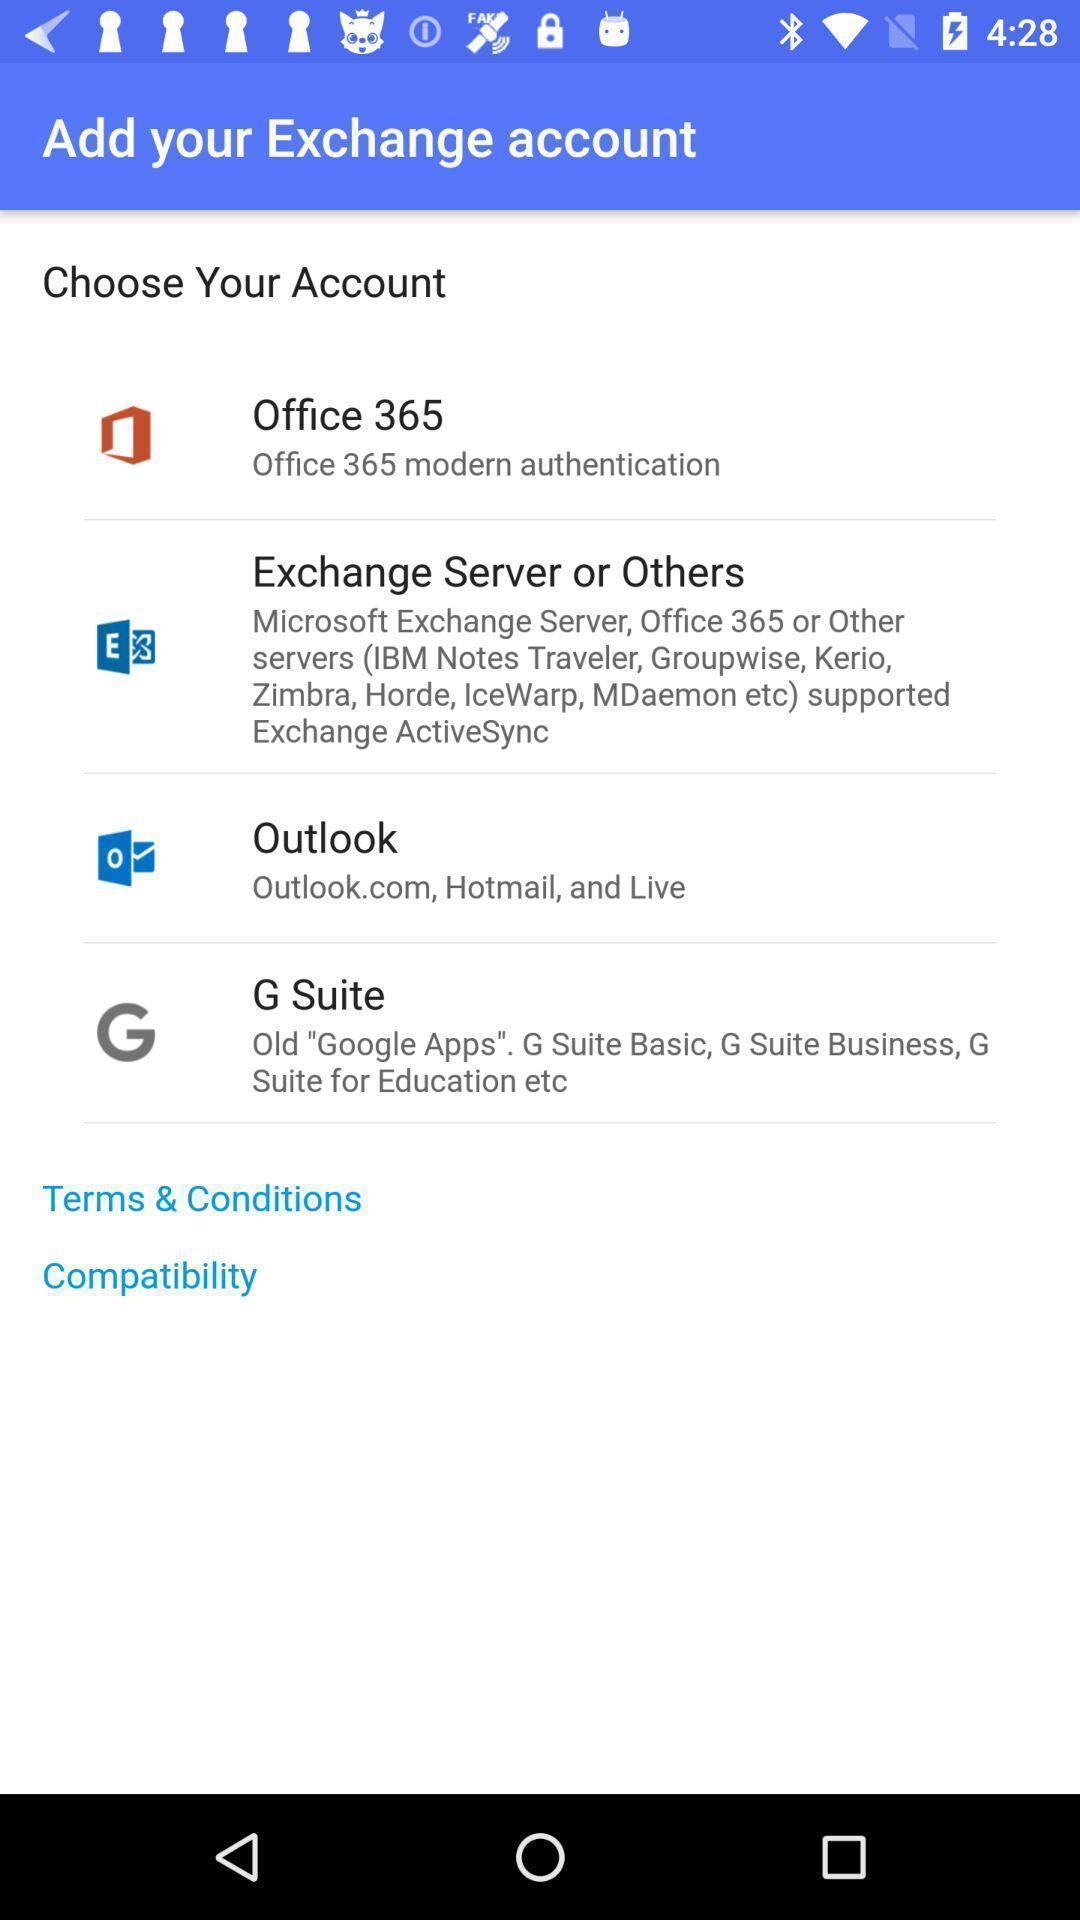What is the overall content of this screenshot? Screen displaying the page to add exchange account. 